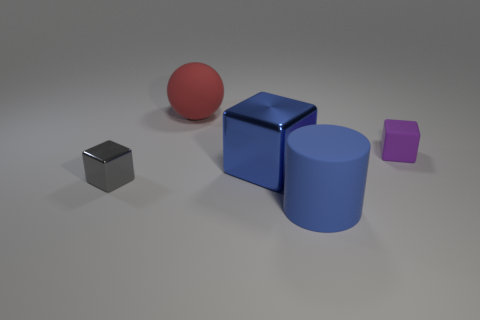Can you describe the shapes and colors present in the image? Certainly! The image showcases a collection of geometric shapes. There's a red sphere, a small silver cube, a larger blue metallic cube, and a large blue cylinder. Next to them is a small purple cube. The arrangement is simple, resting on a flat surface with a plain background to accentuate the objects. 